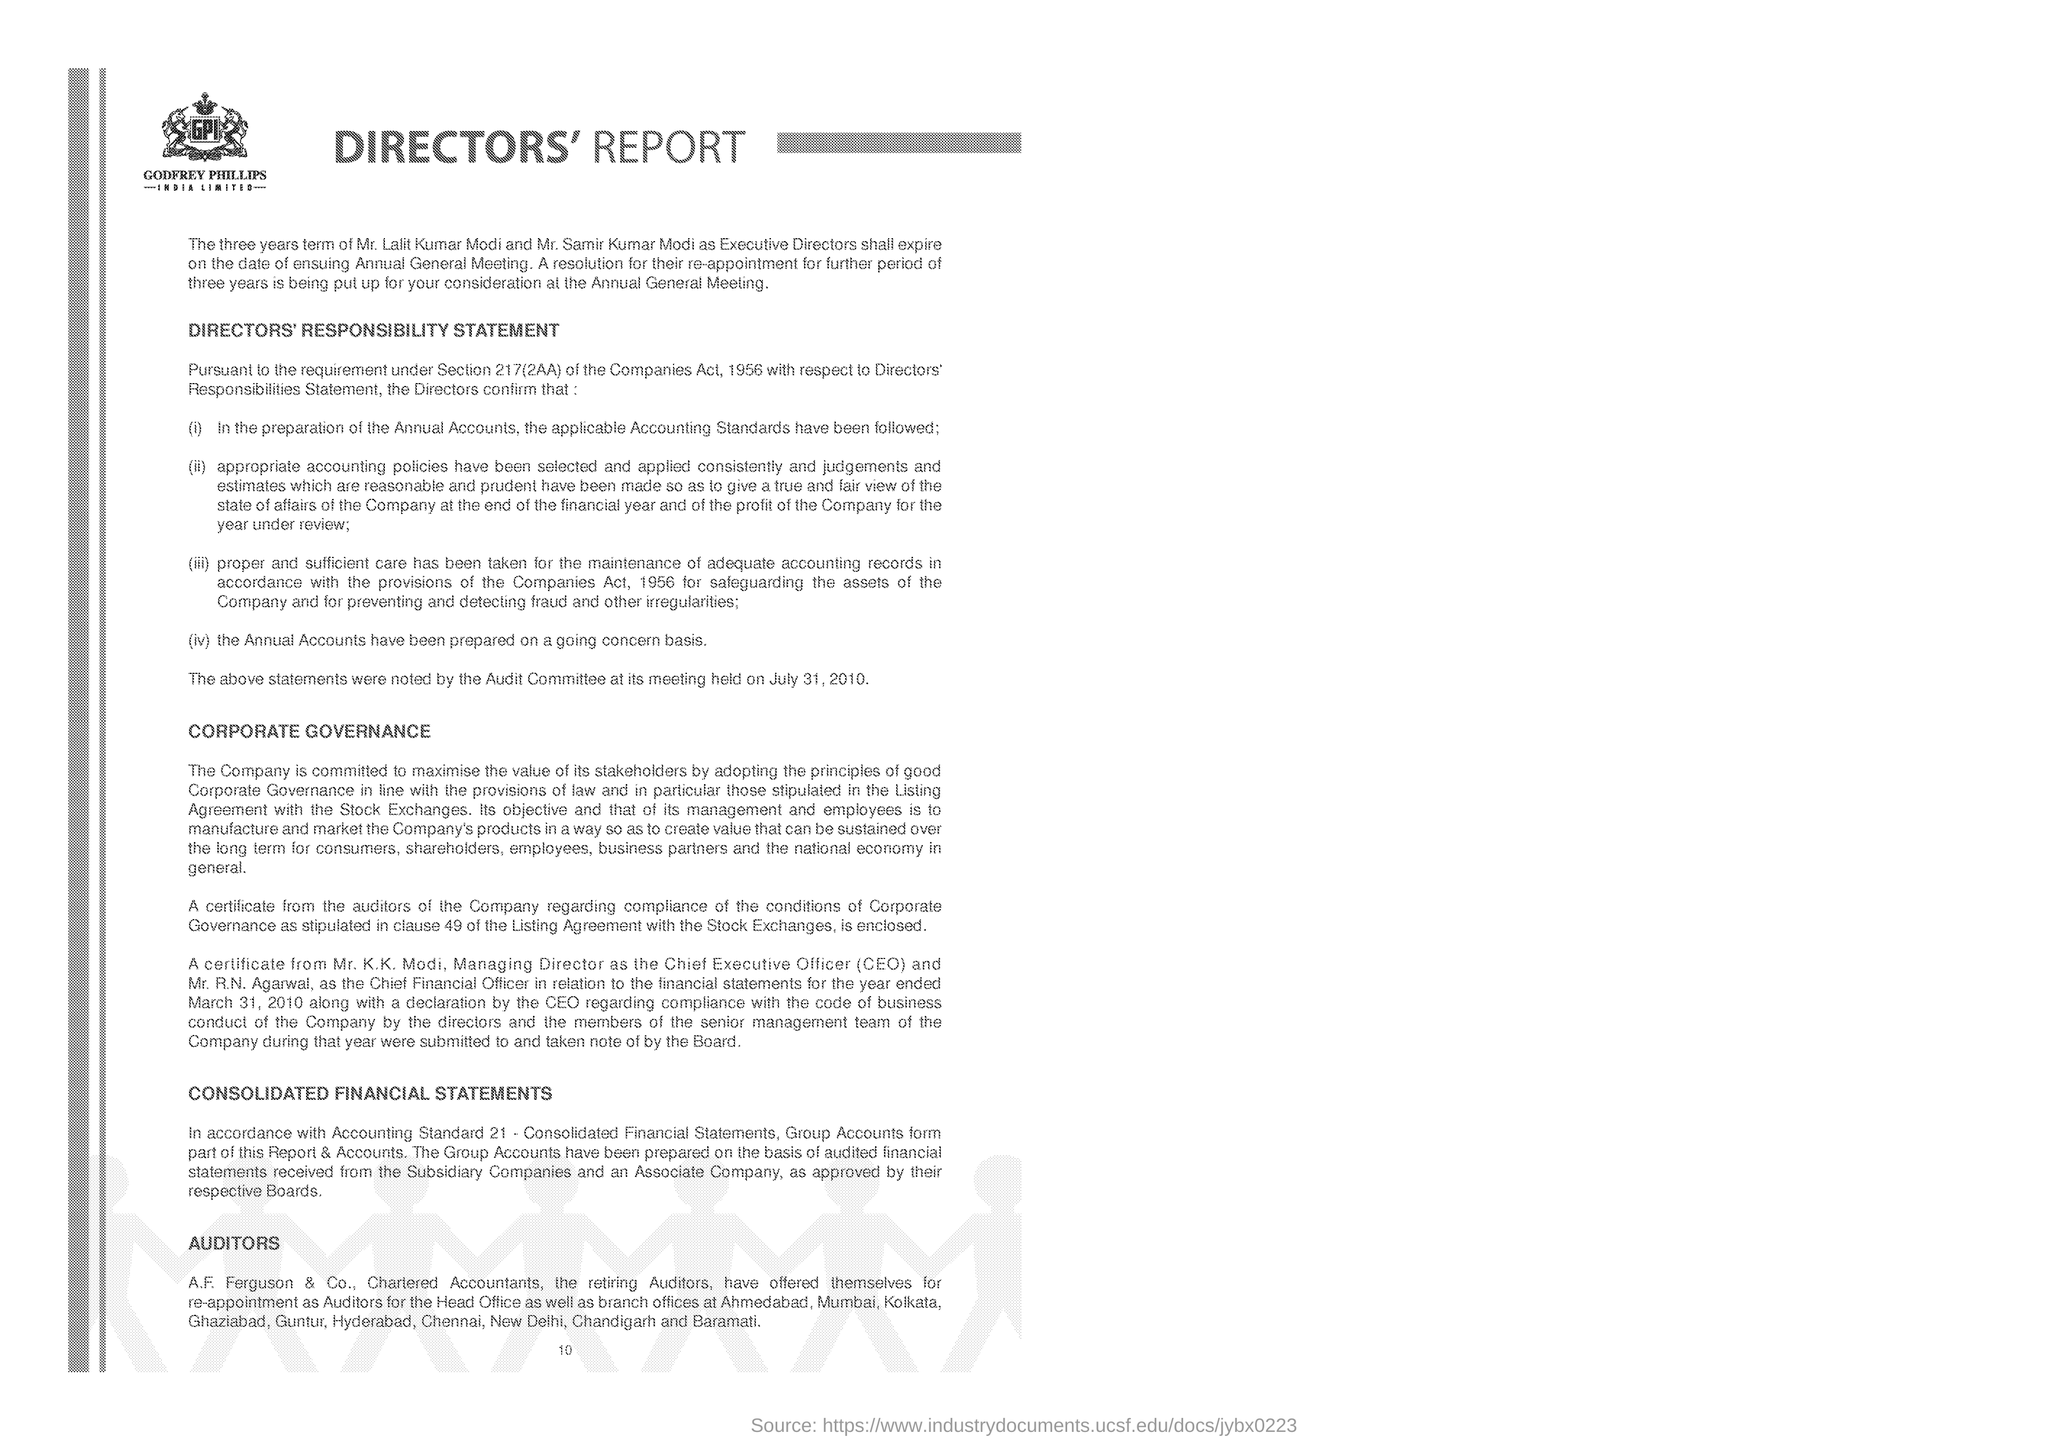Which company is mentioned in the document ?
Provide a short and direct response. GODFREY PHILLIPS INDIA LIMITED. 